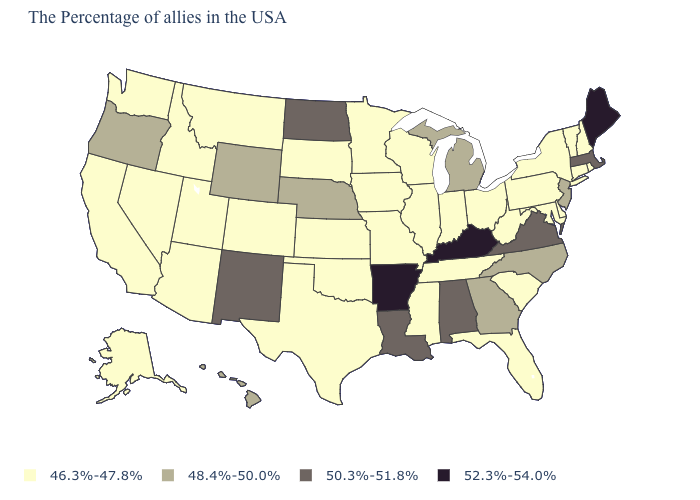Does Massachusetts have the lowest value in the Northeast?
Write a very short answer. No. Which states have the lowest value in the MidWest?
Answer briefly. Ohio, Indiana, Wisconsin, Illinois, Missouri, Minnesota, Iowa, Kansas, South Dakota. What is the value of Delaware?
Be succinct. 46.3%-47.8%. What is the value of North Carolina?
Be succinct. 48.4%-50.0%. Does Wyoming have the lowest value in the West?
Quick response, please. No. Name the states that have a value in the range 48.4%-50.0%?
Give a very brief answer. New Jersey, North Carolina, Georgia, Michigan, Nebraska, Wyoming, Oregon, Hawaii. Name the states that have a value in the range 48.4%-50.0%?
Concise answer only. New Jersey, North Carolina, Georgia, Michigan, Nebraska, Wyoming, Oregon, Hawaii. Which states have the lowest value in the USA?
Keep it brief. Rhode Island, New Hampshire, Vermont, Connecticut, New York, Delaware, Maryland, Pennsylvania, South Carolina, West Virginia, Ohio, Florida, Indiana, Tennessee, Wisconsin, Illinois, Mississippi, Missouri, Minnesota, Iowa, Kansas, Oklahoma, Texas, South Dakota, Colorado, Utah, Montana, Arizona, Idaho, Nevada, California, Washington, Alaska. What is the lowest value in states that border Texas?
Concise answer only. 46.3%-47.8%. Is the legend a continuous bar?
Answer briefly. No. What is the value of Ohio?
Be succinct. 46.3%-47.8%. Name the states that have a value in the range 46.3%-47.8%?
Keep it brief. Rhode Island, New Hampshire, Vermont, Connecticut, New York, Delaware, Maryland, Pennsylvania, South Carolina, West Virginia, Ohio, Florida, Indiana, Tennessee, Wisconsin, Illinois, Mississippi, Missouri, Minnesota, Iowa, Kansas, Oklahoma, Texas, South Dakota, Colorado, Utah, Montana, Arizona, Idaho, Nevada, California, Washington, Alaska. Among the states that border California , which have the lowest value?
Answer briefly. Arizona, Nevada. Name the states that have a value in the range 48.4%-50.0%?
Give a very brief answer. New Jersey, North Carolina, Georgia, Michigan, Nebraska, Wyoming, Oregon, Hawaii. Does Nebraska have the lowest value in the MidWest?
Short answer required. No. 